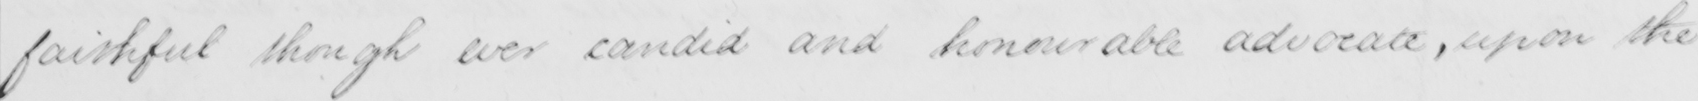Transcribe the text shown in this historical manuscript line. faithful though ever candid and honourable advocate , upon the 